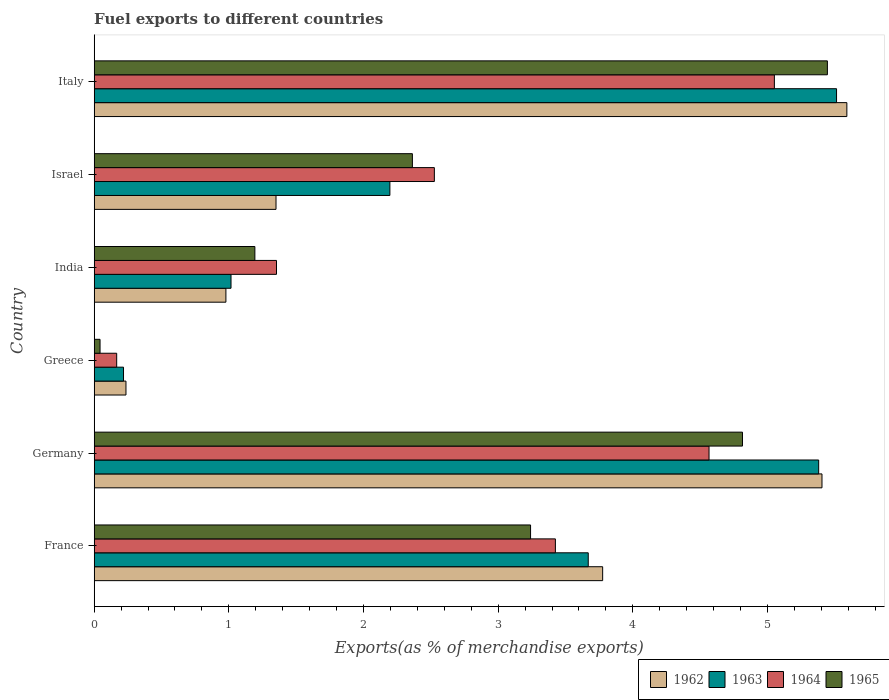How many different coloured bars are there?
Provide a succinct answer. 4. What is the label of the 5th group of bars from the top?
Ensure brevity in your answer.  Germany. In how many cases, is the number of bars for a given country not equal to the number of legend labels?
Give a very brief answer. 0. What is the percentage of exports to different countries in 1965 in Greece?
Your response must be concise. 0.04. Across all countries, what is the maximum percentage of exports to different countries in 1965?
Provide a succinct answer. 5.45. Across all countries, what is the minimum percentage of exports to different countries in 1962?
Your answer should be very brief. 0.24. In which country was the percentage of exports to different countries in 1963 maximum?
Give a very brief answer. Italy. In which country was the percentage of exports to different countries in 1963 minimum?
Give a very brief answer. Greece. What is the total percentage of exports to different countries in 1965 in the graph?
Ensure brevity in your answer.  17.1. What is the difference between the percentage of exports to different countries in 1963 in Greece and that in India?
Keep it short and to the point. -0.8. What is the difference between the percentage of exports to different countries in 1962 in Greece and the percentage of exports to different countries in 1965 in Italy?
Your answer should be compact. -5.21. What is the average percentage of exports to different countries in 1965 per country?
Provide a succinct answer. 2.85. What is the difference between the percentage of exports to different countries in 1962 and percentage of exports to different countries in 1965 in Israel?
Keep it short and to the point. -1.01. What is the ratio of the percentage of exports to different countries in 1962 in France to that in India?
Your response must be concise. 3.86. Is the percentage of exports to different countries in 1963 in India less than that in Israel?
Keep it short and to the point. Yes. Is the difference between the percentage of exports to different countries in 1962 in Germany and Italy greater than the difference between the percentage of exports to different countries in 1965 in Germany and Italy?
Your response must be concise. Yes. What is the difference between the highest and the second highest percentage of exports to different countries in 1963?
Offer a terse response. 0.13. What is the difference between the highest and the lowest percentage of exports to different countries in 1964?
Provide a short and direct response. 4.88. In how many countries, is the percentage of exports to different countries in 1962 greater than the average percentage of exports to different countries in 1962 taken over all countries?
Provide a short and direct response. 3. Is the sum of the percentage of exports to different countries in 1964 in Israel and Italy greater than the maximum percentage of exports to different countries in 1963 across all countries?
Your response must be concise. Yes. What does the 3rd bar from the bottom in France represents?
Make the answer very short. 1964. Is it the case that in every country, the sum of the percentage of exports to different countries in 1965 and percentage of exports to different countries in 1964 is greater than the percentage of exports to different countries in 1963?
Provide a short and direct response. No. What is the difference between two consecutive major ticks on the X-axis?
Make the answer very short. 1. Are the values on the major ticks of X-axis written in scientific E-notation?
Offer a very short reply. No. Does the graph contain any zero values?
Give a very brief answer. No. How are the legend labels stacked?
Ensure brevity in your answer.  Horizontal. What is the title of the graph?
Make the answer very short. Fuel exports to different countries. Does "1971" appear as one of the legend labels in the graph?
Make the answer very short. No. What is the label or title of the X-axis?
Ensure brevity in your answer.  Exports(as % of merchandise exports). What is the Exports(as % of merchandise exports) of 1962 in France?
Your answer should be compact. 3.78. What is the Exports(as % of merchandise exports) in 1963 in France?
Provide a short and direct response. 3.67. What is the Exports(as % of merchandise exports) of 1964 in France?
Keep it short and to the point. 3.43. What is the Exports(as % of merchandise exports) of 1965 in France?
Keep it short and to the point. 3.24. What is the Exports(as % of merchandise exports) of 1962 in Germany?
Offer a terse response. 5.4. What is the Exports(as % of merchandise exports) in 1963 in Germany?
Offer a terse response. 5.38. What is the Exports(as % of merchandise exports) in 1964 in Germany?
Your answer should be very brief. 4.57. What is the Exports(as % of merchandise exports) of 1965 in Germany?
Your response must be concise. 4.81. What is the Exports(as % of merchandise exports) of 1962 in Greece?
Offer a very short reply. 0.24. What is the Exports(as % of merchandise exports) in 1963 in Greece?
Provide a succinct answer. 0.22. What is the Exports(as % of merchandise exports) in 1964 in Greece?
Provide a succinct answer. 0.17. What is the Exports(as % of merchandise exports) in 1965 in Greece?
Your response must be concise. 0.04. What is the Exports(as % of merchandise exports) in 1962 in India?
Make the answer very short. 0.98. What is the Exports(as % of merchandise exports) in 1963 in India?
Keep it short and to the point. 1.02. What is the Exports(as % of merchandise exports) of 1964 in India?
Your answer should be very brief. 1.35. What is the Exports(as % of merchandise exports) in 1965 in India?
Keep it short and to the point. 1.19. What is the Exports(as % of merchandise exports) in 1962 in Israel?
Offer a very short reply. 1.35. What is the Exports(as % of merchandise exports) of 1963 in Israel?
Your answer should be compact. 2.2. What is the Exports(as % of merchandise exports) of 1964 in Israel?
Keep it short and to the point. 2.53. What is the Exports(as % of merchandise exports) in 1965 in Israel?
Provide a short and direct response. 2.36. What is the Exports(as % of merchandise exports) in 1962 in Italy?
Provide a succinct answer. 5.59. What is the Exports(as % of merchandise exports) in 1963 in Italy?
Ensure brevity in your answer.  5.51. What is the Exports(as % of merchandise exports) of 1964 in Italy?
Your answer should be compact. 5.05. What is the Exports(as % of merchandise exports) in 1965 in Italy?
Ensure brevity in your answer.  5.45. Across all countries, what is the maximum Exports(as % of merchandise exports) in 1962?
Provide a short and direct response. 5.59. Across all countries, what is the maximum Exports(as % of merchandise exports) of 1963?
Your response must be concise. 5.51. Across all countries, what is the maximum Exports(as % of merchandise exports) of 1964?
Provide a short and direct response. 5.05. Across all countries, what is the maximum Exports(as % of merchandise exports) in 1965?
Provide a succinct answer. 5.45. Across all countries, what is the minimum Exports(as % of merchandise exports) of 1962?
Provide a succinct answer. 0.24. Across all countries, what is the minimum Exports(as % of merchandise exports) of 1963?
Your answer should be compact. 0.22. Across all countries, what is the minimum Exports(as % of merchandise exports) in 1964?
Your answer should be compact. 0.17. Across all countries, what is the minimum Exports(as % of merchandise exports) of 1965?
Your answer should be compact. 0.04. What is the total Exports(as % of merchandise exports) of 1962 in the graph?
Offer a terse response. 17.34. What is the total Exports(as % of merchandise exports) of 1963 in the graph?
Provide a short and direct response. 17.99. What is the total Exports(as % of merchandise exports) in 1964 in the graph?
Offer a very short reply. 17.09. What is the total Exports(as % of merchandise exports) in 1965 in the graph?
Ensure brevity in your answer.  17.1. What is the difference between the Exports(as % of merchandise exports) in 1962 in France and that in Germany?
Provide a succinct answer. -1.63. What is the difference between the Exports(as % of merchandise exports) of 1963 in France and that in Germany?
Your answer should be compact. -1.71. What is the difference between the Exports(as % of merchandise exports) in 1964 in France and that in Germany?
Offer a very short reply. -1.14. What is the difference between the Exports(as % of merchandise exports) of 1965 in France and that in Germany?
Offer a very short reply. -1.57. What is the difference between the Exports(as % of merchandise exports) of 1962 in France and that in Greece?
Give a very brief answer. 3.54. What is the difference between the Exports(as % of merchandise exports) in 1963 in France and that in Greece?
Ensure brevity in your answer.  3.45. What is the difference between the Exports(as % of merchandise exports) in 1964 in France and that in Greece?
Give a very brief answer. 3.26. What is the difference between the Exports(as % of merchandise exports) in 1965 in France and that in Greece?
Offer a terse response. 3.2. What is the difference between the Exports(as % of merchandise exports) of 1962 in France and that in India?
Keep it short and to the point. 2.8. What is the difference between the Exports(as % of merchandise exports) in 1963 in France and that in India?
Your answer should be very brief. 2.65. What is the difference between the Exports(as % of merchandise exports) of 1964 in France and that in India?
Give a very brief answer. 2.07. What is the difference between the Exports(as % of merchandise exports) in 1965 in France and that in India?
Your response must be concise. 2.05. What is the difference between the Exports(as % of merchandise exports) in 1962 in France and that in Israel?
Your response must be concise. 2.43. What is the difference between the Exports(as % of merchandise exports) in 1963 in France and that in Israel?
Keep it short and to the point. 1.47. What is the difference between the Exports(as % of merchandise exports) of 1964 in France and that in Israel?
Offer a very short reply. 0.9. What is the difference between the Exports(as % of merchandise exports) of 1965 in France and that in Israel?
Your response must be concise. 0.88. What is the difference between the Exports(as % of merchandise exports) in 1962 in France and that in Italy?
Your answer should be compact. -1.81. What is the difference between the Exports(as % of merchandise exports) in 1963 in France and that in Italy?
Give a very brief answer. -1.84. What is the difference between the Exports(as % of merchandise exports) in 1964 in France and that in Italy?
Your response must be concise. -1.63. What is the difference between the Exports(as % of merchandise exports) in 1965 in France and that in Italy?
Offer a very short reply. -2.2. What is the difference between the Exports(as % of merchandise exports) of 1962 in Germany and that in Greece?
Provide a succinct answer. 5.17. What is the difference between the Exports(as % of merchandise exports) in 1963 in Germany and that in Greece?
Provide a succinct answer. 5.16. What is the difference between the Exports(as % of merchandise exports) of 1964 in Germany and that in Greece?
Provide a succinct answer. 4.4. What is the difference between the Exports(as % of merchandise exports) of 1965 in Germany and that in Greece?
Your answer should be compact. 4.77. What is the difference between the Exports(as % of merchandise exports) of 1962 in Germany and that in India?
Make the answer very short. 4.43. What is the difference between the Exports(as % of merchandise exports) of 1963 in Germany and that in India?
Provide a succinct answer. 4.36. What is the difference between the Exports(as % of merchandise exports) in 1964 in Germany and that in India?
Your answer should be very brief. 3.21. What is the difference between the Exports(as % of merchandise exports) in 1965 in Germany and that in India?
Offer a terse response. 3.62. What is the difference between the Exports(as % of merchandise exports) of 1962 in Germany and that in Israel?
Your answer should be very brief. 4.05. What is the difference between the Exports(as % of merchandise exports) in 1963 in Germany and that in Israel?
Ensure brevity in your answer.  3.18. What is the difference between the Exports(as % of merchandise exports) in 1964 in Germany and that in Israel?
Your response must be concise. 2.04. What is the difference between the Exports(as % of merchandise exports) in 1965 in Germany and that in Israel?
Give a very brief answer. 2.45. What is the difference between the Exports(as % of merchandise exports) of 1962 in Germany and that in Italy?
Your response must be concise. -0.18. What is the difference between the Exports(as % of merchandise exports) of 1963 in Germany and that in Italy?
Make the answer very short. -0.13. What is the difference between the Exports(as % of merchandise exports) in 1964 in Germany and that in Italy?
Ensure brevity in your answer.  -0.49. What is the difference between the Exports(as % of merchandise exports) of 1965 in Germany and that in Italy?
Keep it short and to the point. -0.63. What is the difference between the Exports(as % of merchandise exports) of 1962 in Greece and that in India?
Ensure brevity in your answer.  -0.74. What is the difference between the Exports(as % of merchandise exports) of 1963 in Greece and that in India?
Keep it short and to the point. -0.8. What is the difference between the Exports(as % of merchandise exports) of 1964 in Greece and that in India?
Ensure brevity in your answer.  -1.19. What is the difference between the Exports(as % of merchandise exports) of 1965 in Greece and that in India?
Provide a short and direct response. -1.15. What is the difference between the Exports(as % of merchandise exports) in 1962 in Greece and that in Israel?
Your answer should be very brief. -1.11. What is the difference between the Exports(as % of merchandise exports) of 1963 in Greece and that in Israel?
Ensure brevity in your answer.  -1.98. What is the difference between the Exports(as % of merchandise exports) in 1964 in Greece and that in Israel?
Give a very brief answer. -2.36. What is the difference between the Exports(as % of merchandise exports) in 1965 in Greece and that in Israel?
Offer a very short reply. -2.32. What is the difference between the Exports(as % of merchandise exports) of 1962 in Greece and that in Italy?
Make the answer very short. -5.35. What is the difference between the Exports(as % of merchandise exports) in 1963 in Greece and that in Italy?
Provide a short and direct response. -5.3. What is the difference between the Exports(as % of merchandise exports) in 1964 in Greece and that in Italy?
Offer a terse response. -4.88. What is the difference between the Exports(as % of merchandise exports) of 1965 in Greece and that in Italy?
Your answer should be compact. -5.4. What is the difference between the Exports(as % of merchandise exports) of 1962 in India and that in Israel?
Your answer should be compact. -0.37. What is the difference between the Exports(as % of merchandise exports) in 1963 in India and that in Israel?
Provide a short and direct response. -1.18. What is the difference between the Exports(as % of merchandise exports) in 1964 in India and that in Israel?
Provide a short and direct response. -1.17. What is the difference between the Exports(as % of merchandise exports) of 1965 in India and that in Israel?
Give a very brief answer. -1.17. What is the difference between the Exports(as % of merchandise exports) in 1962 in India and that in Italy?
Your answer should be very brief. -4.61. What is the difference between the Exports(as % of merchandise exports) of 1963 in India and that in Italy?
Your response must be concise. -4.5. What is the difference between the Exports(as % of merchandise exports) in 1964 in India and that in Italy?
Your response must be concise. -3.7. What is the difference between the Exports(as % of merchandise exports) of 1965 in India and that in Italy?
Offer a terse response. -4.25. What is the difference between the Exports(as % of merchandise exports) of 1962 in Israel and that in Italy?
Ensure brevity in your answer.  -4.24. What is the difference between the Exports(as % of merchandise exports) of 1963 in Israel and that in Italy?
Keep it short and to the point. -3.32. What is the difference between the Exports(as % of merchandise exports) of 1964 in Israel and that in Italy?
Provide a short and direct response. -2.53. What is the difference between the Exports(as % of merchandise exports) of 1965 in Israel and that in Italy?
Offer a terse response. -3.08. What is the difference between the Exports(as % of merchandise exports) of 1962 in France and the Exports(as % of merchandise exports) of 1963 in Germany?
Your answer should be very brief. -1.6. What is the difference between the Exports(as % of merchandise exports) of 1962 in France and the Exports(as % of merchandise exports) of 1964 in Germany?
Ensure brevity in your answer.  -0.79. What is the difference between the Exports(as % of merchandise exports) of 1962 in France and the Exports(as % of merchandise exports) of 1965 in Germany?
Make the answer very short. -1.04. What is the difference between the Exports(as % of merchandise exports) in 1963 in France and the Exports(as % of merchandise exports) in 1964 in Germany?
Keep it short and to the point. -0.9. What is the difference between the Exports(as % of merchandise exports) of 1963 in France and the Exports(as % of merchandise exports) of 1965 in Germany?
Offer a terse response. -1.15. What is the difference between the Exports(as % of merchandise exports) in 1964 in France and the Exports(as % of merchandise exports) in 1965 in Germany?
Keep it short and to the point. -1.39. What is the difference between the Exports(as % of merchandise exports) of 1962 in France and the Exports(as % of merchandise exports) of 1963 in Greece?
Make the answer very short. 3.56. What is the difference between the Exports(as % of merchandise exports) of 1962 in France and the Exports(as % of merchandise exports) of 1964 in Greece?
Ensure brevity in your answer.  3.61. What is the difference between the Exports(as % of merchandise exports) in 1962 in France and the Exports(as % of merchandise exports) in 1965 in Greece?
Your response must be concise. 3.73. What is the difference between the Exports(as % of merchandise exports) in 1963 in France and the Exports(as % of merchandise exports) in 1964 in Greece?
Your response must be concise. 3.5. What is the difference between the Exports(as % of merchandise exports) of 1963 in France and the Exports(as % of merchandise exports) of 1965 in Greece?
Offer a very short reply. 3.63. What is the difference between the Exports(as % of merchandise exports) of 1964 in France and the Exports(as % of merchandise exports) of 1965 in Greece?
Provide a succinct answer. 3.38. What is the difference between the Exports(as % of merchandise exports) in 1962 in France and the Exports(as % of merchandise exports) in 1963 in India?
Your answer should be very brief. 2.76. What is the difference between the Exports(as % of merchandise exports) in 1962 in France and the Exports(as % of merchandise exports) in 1964 in India?
Your answer should be very brief. 2.42. What is the difference between the Exports(as % of merchandise exports) in 1962 in France and the Exports(as % of merchandise exports) in 1965 in India?
Your response must be concise. 2.58. What is the difference between the Exports(as % of merchandise exports) of 1963 in France and the Exports(as % of merchandise exports) of 1964 in India?
Give a very brief answer. 2.32. What is the difference between the Exports(as % of merchandise exports) in 1963 in France and the Exports(as % of merchandise exports) in 1965 in India?
Provide a short and direct response. 2.48. What is the difference between the Exports(as % of merchandise exports) of 1964 in France and the Exports(as % of merchandise exports) of 1965 in India?
Give a very brief answer. 2.23. What is the difference between the Exports(as % of merchandise exports) of 1962 in France and the Exports(as % of merchandise exports) of 1963 in Israel?
Make the answer very short. 1.58. What is the difference between the Exports(as % of merchandise exports) of 1962 in France and the Exports(as % of merchandise exports) of 1964 in Israel?
Your answer should be compact. 1.25. What is the difference between the Exports(as % of merchandise exports) of 1962 in France and the Exports(as % of merchandise exports) of 1965 in Israel?
Provide a short and direct response. 1.41. What is the difference between the Exports(as % of merchandise exports) in 1963 in France and the Exports(as % of merchandise exports) in 1964 in Israel?
Give a very brief answer. 1.14. What is the difference between the Exports(as % of merchandise exports) in 1963 in France and the Exports(as % of merchandise exports) in 1965 in Israel?
Keep it short and to the point. 1.31. What is the difference between the Exports(as % of merchandise exports) of 1964 in France and the Exports(as % of merchandise exports) of 1965 in Israel?
Provide a short and direct response. 1.06. What is the difference between the Exports(as % of merchandise exports) in 1962 in France and the Exports(as % of merchandise exports) in 1963 in Italy?
Your answer should be very brief. -1.74. What is the difference between the Exports(as % of merchandise exports) in 1962 in France and the Exports(as % of merchandise exports) in 1964 in Italy?
Your answer should be compact. -1.28. What is the difference between the Exports(as % of merchandise exports) in 1962 in France and the Exports(as % of merchandise exports) in 1965 in Italy?
Ensure brevity in your answer.  -1.67. What is the difference between the Exports(as % of merchandise exports) of 1963 in France and the Exports(as % of merchandise exports) of 1964 in Italy?
Give a very brief answer. -1.38. What is the difference between the Exports(as % of merchandise exports) of 1963 in France and the Exports(as % of merchandise exports) of 1965 in Italy?
Provide a succinct answer. -1.78. What is the difference between the Exports(as % of merchandise exports) in 1964 in France and the Exports(as % of merchandise exports) in 1965 in Italy?
Ensure brevity in your answer.  -2.02. What is the difference between the Exports(as % of merchandise exports) in 1962 in Germany and the Exports(as % of merchandise exports) in 1963 in Greece?
Your answer should be compact. 5.19. What is the difference between the Exports(as % of merchandise exports) in 1962 in Germany and the Exports(as % of merchandise exports) in 1964 in Greece?
Provide a succinct answer. 5.24. What is the difference between the Exports(as % of merchandise exports) of 1962 in Germany and the Exports(as % of merchandise exports) of 1965 in Greece?
Your answer should be compact. 5.36. What is the difference between the Exports(as % of merchandise exports) in 1963 in Germany and the Exports(as % of merchandise exports) in 1964 in Greece?
Your answer should be compact. 5.21. What is the difference between the Exports(as % of merchandise exports) in 1963 in Germany and the Exports(as % of merchandise exports) in 1965 in Greece?
Make the answer very short. 5.34. What is the difference between the Exports(as % of merchandise exports) in 1964 in Germany and the Exports(as % of merchandise exports) in 1965 in Greece?
Give a very brief answer. 4.52. What is the difference between the Exports(as % of merchandise exports) of 1962 in Germany and the Exports(as % of merchandise exports) of 1963 in India?
Offer a terse response. 4.39. What is the difference between the Exports(as % of merchandise exports) in 1962 in Germany and the Exports(as % of merchandise exports) in 1964 in India?
Give a very brief answer. 4.05. What is the difference between the Exports(as % of merchandise exports) in 1962 in Germany and the Exports(as % of merchandise exports) in 1965 in India?
Offer a terse response. 4.21. What is the difference between the Exports(as % of merchandise exports) of 1963 in Germany and the Exports(as % of merchandise exports) of 1964 in India?
Ensure brevity in your answer.  4.03. What is the difference between the Exports(as % of merchandise exports) of 1963 in Germany and the Exports(as % of merchandise exports) of 1965 in India?
Provide a succinct answer. 4.19. What is the difference between the Exports(as % of merchandise exports) of 1964 in Germany and the Exports(as % of merchandise exports) of 1965 in India?
Provide a short and direct response. 3.37. What is the difference between the Exports(as % of merchandise exports) of 1962 in Germany and the Exports(as % of merchandise exports) of 1963 in Israel?
Provide a short and direct response. 3.21. What is the difference between the Exports(as % of merchandise exports) of 1962 in Germany and the Exports(as % of merchandise exports) of 1964 in Israel?
Give a very brief answer. 2.88. What is the difference between the Exports(as % of merchandise exports) in 1962 in Germany and the Exports(as % of merchandise exports) in 1965 in Israel?
Keep it short and to the point. 3.04. What is the difference between the Exports(as % of merchandise exports) in 1963 in Germany and the Exports(as % of merchandise exports) in 1964 in Israel?
Offer a very short reply. 2.85. What is the difference between the Exports(as % of merchandise exports) in 1963 in Germany and the Exports(as % of merchandise exports) in 1965 in Israel?
Offer a terse response. 3.02. What is the difference between the Exports(as % of merchandise exports) of 1964 in Germany and the Exports(as % of merchandise exports) of 1965 in Israel?
Provide a short and direct response. 2.2. What is the difference between the Exports(as % of merchandise exports) of 1962 in Germany and the Exports(as % of merchandise exports) of 1963 in Italy?
Offer a terse response. -0.11. What is the difference between the Exports(as % of merchandise exports) in 1962 in Germany and the Exports(as % of merchandise exports) in 1964 in Italy?
Offer a very short reply. 0.35. What is the difference between the Exports(as % of merchandise exports) of 1962 in Germany and the Exports(as % of merchandise exports) of 1965 in Italy?
Your answer should be compact. -0.04. What is the difference between the Exports(as % of merchandise exports) of 1963 in Germany and the Exports(as % of merchandise exports) of 1964 in Italy?
Make the answer very short. 0.33. What is the difference between the Exports(as % of merchandise exports) of 1963 in Germany and the Exports(as % of merchandise exports) of 1965 in Italy?
Keep it short and to the point. -0.06. What is the difference between the Exports(as % of merchandise exports) of 1964 in Germany and the Exports(as % of merchandise exports) of 1965 in Italy?
Your response must be concise. -0.88. What is the difference between the Exports(as % of merchandise exports) of 1962 in Greece and the Exports(as % of merchandise exports) of 1963 in India?
Your response must be concise. -0.78. What is the difference between the Exports(as % of merchandise exports) in 1962 in Greece and the Exports(as % of merchandise exports) in 1964 in India?
Your response must be concise. -1.12. What is the difference between the Exports(as % of merchandise exports) in 1962 in Greece and the Exports(as % of merchandise exports) in 1965 in India?
Give a very brief answer. -0.96. What is the difference between the Exports(as % of merchandise exports) of 1963 in Greece and the Exports(as % of merchandise exports) of 1964 in India?
Your response must be concise. -1.14. What is the difference between the Exports(as % of merchandise exports) in 1963 in Greece and the Exports(as % of merchandise exports) in 1965 in India?
Provide a short and direct response. -0.98. What is the difference between the Exports(as % of merchandise exports) in 1964 in Greece and the Exports(as % of merchandise exports) in 1965 in India?
Your answer should be compact. -1.03. What is the difference between the Exports(as % of merchandise exports) of 1962 in Greece and the Exports(as % of merchandise exports) of 1963 in Israel?
Give a very brief answer. -1.96. What is the difference between the Exports(as % of merchandise exports) of 1962 in Greece and the Exports(as % of merchandise exports) of 1964 in Israel?
Your answer should be compact. -2.29. What is the difference between the Exports(as % of merchandise exports) of 1962 in Greece and the Exports(as % of merchandise exports) of 1965 in Israel?
Your response must be concise. -2.13. What is the difference between the Exports(as % of merchandise exports) in 1963 in Greece and the Exports(as % of merchandise exports) in 1964 in Israel?
Offer a terse response. -2.31. What is the difference between the Exports(as % of merchandise exports) of 1963 in Greece and the Exports(as % of merchandise exports) of 1965 in Israel?
Offer a terse response. -2.15. What is the difference between the Exports(as % of merchandise exports) of 1964 in Greece and the Exports(as % of merchandise exports) of 1965 in Israel?
Keep it short and to the point. -2.2. What is the difference between the Exports(as % of merchandise exports) of 1962 in Greece and the Exports(as % of merchandise exports) of 1963 in Italy?
Offer a very short reply. -5.28. What is the difference between the Exports(as % of merchandise exports) in 1962 in Greece and the Exports(as % of merchandise exports) in 1964 in Italy?
Make the answer very short. -4.82. What is the difference between the Exports(as % of merchandise exports) in 1962 in Greece and the Exports(as % of merchandise exports) in 1965 in Italy?
Provide a short and direct response. -5.21. What is the difference between the Exports(as % of merchandise exports) of 1963 in Greece and the Exports(as % of merchandise exports) of 1964 in Italy?
Your answer should be very brief. -4.83. What is the difference between the Exports(as % of merchandise exports) in 1963 in Greece and the Exports(as % of merchandise exports) in 1965 in Italy?
Offer a terse response. -5.23. What is the difference between the Exports(as % of merchandise exports) of 1964 in Greece and the Exports(as % of merchandise exports) of 1965 in Italy?
Provide a short and direct response. -5.28. What is the difference between the Exports(as % of merchandise exports) in 1962 in India and the Exports(as % of merchandise exports) in 1963 in Israel?
Give a very brief answer. -1.22. What is the difference between the Exports(as % of merchandise exports) of 1962 in India and the Exports(as % of merchandise exports) of 1964 in Israel?
Provide a short and direct response. -1.55. What is the difference between the Exports(as % of merchandise exports) in 1962 in India and the Exports(as % of merchandise exports) in 1965 in Israel?
Offer a terse response. -1.38. What is the difference between the Exports(as % of merchandise exports) in 1963 in India and the Exports(as % of merchandise exports) in 1964 in Israel?
Your answer should be very brief. -1.51. What is the difference between the Exports(as % of merchandise exports) of 1963 in India and the Exports(as % of merchandise exports) of 1965 in Israel?
Keep it short and to the point. -1.35. What is the difference between the Exports(as % of merchandise exports) of 1964 in India and the Exports(as % of merchandise exports) of 1965 in Israel?
Your answer should be very brief. -1.01. What is the difference between the Exports(as % of merchandise exports) in 1962 in India and the Exports(as % of merchandise exports) in 1963 in Italy?
Your answer should be compact. -4.54. What is the difference between the Exports(as % of merchandise exports) in 1962 in India and the Exports(as % of merchandise exports) in 1964 in Italy?
Your answer should be compact. -4.07. What is the difference between the Exports(as % of merchandise exports) in 1962 in India and the Exports(as % of merchandise exports) in 1965 in Italy?
Ensure brevity in your answer.  -4.47. What is the difference between the Exports(as % of merchandise exports) of 1963 in India and the Exports(as % of merchandise exports) of 1964 in Italy?
Make the answer very short. -4.04. What is the difference between the Exports(as % of merchandise exports) in 1963 in India and the Exports(as % of merchandise exports) in 1965 in Italy?
Make the answer very short. -4.43. What is the difference between the Exports(as % of merchandise exports) in 1964 in India and the Exports(as % of merchandise exports) in 1965 in Italy?
Make the answer very short. -4.09. What is the difference between the Exports(as % of merchandise exports) of 1962 in Israel and the Exports(as % of merchandise exports) of 1963 in Italy?
Offer a terse response. -4.16. What is the difference between the Exports(as % of merchandise exports) of 1962 in Israel and the Exports(as % of merchandise exports) of 1964 in Italy?
Your response must be concise. -3.7. What is the difference between the Exports(as % of merchandise exports) in 1962 in Israel and the Exports(as % of merchandise exports) in 1965 in Italy?
Your answer should be compact. -4.09. What is the difference between the Exports(as % of merchandise exports) in 1963 in Israel and the Exports(as % of merchandise exports) in 1964 in Italy?
Make the answer very short. -2.86. What is the difference between the Exports(as % of merchandise exports) of 1963 in Israel and the Exports(as % of merchandise exports) of 1965 in Italy?
Provide a succinct answer. -3.25. What is the difference between the Exports(as % of merchandise exports) in 1964 in Israel and the Exports(as % of merchandise exports) in 1965 in Italy?
Offer a terse response. -2.92. What is the average Exports(as % of merchandise exports) of 1962 per country?
Keep it short and to the point. 2.89. What is the average Exports(as % of merchandise exports) of 1963 per country?
Provide a succinct answer. 3. What is the average Exports(as % of merchandise exports) in 1964 per country?
Your response must be concise. 2.85. What is the average Exports(as % of merchandise exports) of 1965 per country?
Your answer should be very brief. 2.85. What is the difference between the Exports(as % of merchandise exports) of 1962 and Exports(as % of merchandise exports) of 1963 in France?
Make the answer very short. 0.11. What is the difference between the Exports(as % of merchandise exports) in 1962 and Exports(as % of merchandise exports) in 1964 in France?
Your answer should be very brief. 0.35. What is the difference between the Exports(as % of merchandise exports) of 1962 and Exports(as % of merchandise exports) of 1965 in France?
Ensure brevity in your answer.  0.54. What is the difference between the Exports(as % of merchandise exports) of 1963 and Exports(as % of merchandise exports) of 1964 in France?
Your response must be concise. 0.24. What is the difference between the Exports(as % of merchandise exports) of 1963 and Exports(as % of merchandise exports) of 1965 in France?
Offer a terse response. 0.43. What is the difference between the Exports(as % of merchandise exports) in 1964 and Exports(as % of merchandise exports) in 1965 in France?
Give a very brief answer. 0.18. What is the difference between the Exports(as % of merchandise exports) of 1962 and Exports(as % of merchandise exports) of 1963 in Germany?
Keep it short and to the point. 0.02. What is the difference between the Exports(as % of merchandise exports) in 1962 and Exports(as % of merchandise exports) in 1964 in Germany?
Your answer should be compact. 0.84. What is the difference between the Exports(as % of merchandise exports) in 1962 and Exports(as % of merchandise exports) in 1965 in Germany?
Provide a short and direct response. 0.59. What is the difference between the Exports(as % of merchandise exports) in 1963 and Exports(as % of merchandise exports) in 1964 in Germany?
Make the answer very short. 0.81. What is the difference between the Exports(as % of merchandise exports) in 1963 and Exports(as % of merchandise exports) in 1965 in Germany?
Ensure brevity in your answer.  0.57. What is the difference between the Exports(as % of merchandise exports) of 1964 and Exports(as % of merchandise exports) of 1965 in Germany?
Your answer should be compact. -0.25. What is the difference between the Exports(as % of merchandise exports) in 1962 and Exports(as % of merchandise exports) in 1963 in Greece?
Keep it short and to the point. 0.02. What is the difference between the Exports(as % of merchandise exports) in 1962 and Exports(as % of merchandise exports) in 1964 in Greece?
Give a very brief answer. 0.07. What is the difference between the Exports(as % of merchandise exports) in 1962 and Exports(as % of merchandise exports) in 1965 in Greece?
Provide a succinct answer. 0.19. What is the difference between the Exports(as % of merchandise exports) in 1963 and Exports(as % of merchandise exports) in 1964 in Greece?
Provide a succinct answer. 0.05. What is the difference between the Exports(as % of merchandise exports) of 1963 and Exports(as % of merchandise exports) of 1965 in Greece?
Offer a terse response. 0.17. What is the difference between the Exports(as % of merchandise exports) of 1964 and Exports(as % of merchandise exports) of 1965 in Greece?
Make the answer very short. 0.12. What is the difference between the Exports(as % of merchandise exports) of 1962 and Exports(as % of merchandise exports) of 1963 in India?
Offer a terse response. -0.04. What is the difference between the Exports(as % of merchandise exports) in 1962 and Exports(as % of merchandise exports) in 1964 in India?
Offer a terse response. -0.38. What is the difference between the Exports(as % of merchandise exports) of 1962 and Exports(as % of merchandise exports) of 1965 in India?
Offer a very short reply. -0.22. What is the difference between the Exports(as % of merchandise exports) in 1963 and Exports(as % of merchandise exports) in 1964 in India?
Offer a very short reply. -0.34. What is the difference between the Exports(as % of merchandise exports) in 1963 and Exports(as % of merchandise exports) in 1965 in India?
Your answer should be compact. -0.18. What is the difference between the Exports(as % of merchandise exports) in 1964 and Exports(as % of merchandise exports) in 1965 in India?
Give a very brief answer. 0.16. What is the difference between the Exports(as % of merchandise exports) of 1962 and Exports(as % of merchandise exports) of 1963 in Israel?
Offer a very short reply. -0.85. What is the difference between the Exports(as % of merchandise exports) of 1962 and Exports(as % of merchandise exports) of 1964 in Israel?
Offer a terse response. -1.18. What is the difference between the Exports(as % of merchandise exports) of 1962 and Exports(as % of merchandise exports) of 1965 in Israel?
Provide a short and direct response. -1.01. What is the difference between the Exports(as % of merchandise exports) in 1963 and Exports(as % of merchandise exports) in 1964 in Israel?
Ensure brevity in your answer.  -0.33. What is the difference between the Exports(as % of merchandise exports) in 1963 and Exports(as % of merchandise exports) in 1965 in Israel?
Provide a short and direct response. -0.17. What is the difference between the Exports(as % of merchandise exports) of 1964 and Exports(as % of merchandise exports) of 1965 in Israel?
Offer a very short reply. 0.16. What is the difference between the Exports(as % of merchandise exports) in 1962 and Exports(as % of merchandise exports) in 1963 in Italy?
Offer a very short reply. 0.08. What is the difference between the Exports(as % of merchandise exports) in 1962 and Exports(as % of merchandise exports) in 1964 in Italy?
Give a very brief answer. 0.54. What is the difference between the Exports(as % of merchandise exports) of 1962 and Exports(as % of merchandise exports) of 1965 in Italy?
Keep it short and to the point. 0.14. What is the difference between the Exports(as % of merchandise exports) of 1963 and Exports(as % of merchandise exports) of 1964 in Italy?
Give a very brief answer. 0.46. What is the difference between the Exports(as % of merchandise exports) in 1963 and Exports(as % of merchandise exports) in 1965 in Italy?
Offer a very short reply. 0.07. What is the difference between the Exports(as % of merchandise exports) in 1964 and Exports(as % of merchandise exports) in 1965 in Italy?
Ensure brevity in your answer.  -0.39. What is the ratio of the Exports(as % of merchandise exports) of 1962 in France to that in Germany?
Keep it short and to the point. 0.7. What is the ratio of the Exports(as % of merchandise exports) of 1963 in France to that in Germany?
Ensure brevity in your answer.  0.68. What is the ratio of the Exports(as % of merchandise exports) of 1964 in France to that in Germany?
Offer a very short reply. 0.75. What is the ratio of the Exports(as % of merchandise exports) in 1965 in France to that in Germany?
Make the answer very short. 0.67. What is the ratio of the Exports(as % of merchandise exports) of 1962 in France to that in Greece?
Your answer should be very brief. 16.01. What is the ratio of the Exports(as % of merchandise exports) of 1963 in France to that in Greece?
Provide a short and direct response. 16.85. What is the ratio of the Exports(as % of merchandise exports) in 1964 in France to that in Greece?
Keep it short and to the point. 20.5. What is the ratio of the Exports(as % of merchandise exports) of 1965 in France to that in Greece?
Provide a succinct answer. 74.69. What is the ratio of the Exports(as % of merchandise exports) of 1962 in France to that in India?
Your answer should be compact. 3.86. What is the ratio of the Exports(as % of merchandise exports) in 1963 in France to that in India?
Provide a succinct answer. 3.61. What is the ratio of the Exports(as % of merchandise exports) in 1964 in France to that in India?
Your answer should be compact. 2.53. What is the ratio of the Exports(as % of merchandise exports) of 1965 in France to that in India?
Offer a terse response. 2.72. What is the ratio of the Exports(as % of merchandise exports) of 1962 in France to that in Israel?
Give a very brief answer. 2.8. What is the ratio of the Exports(as % of merchandise exports) of 1963 in France to that in Israel?
Your answer should be compact. 1.67. What is the ratio of the Exports(as % of merchandise exports) in 1964 in France to that in Israel?
Your answer should be compact. 1.36. What is the ratio of the Exports(as % of merchandise exports) of 1965 in France to that in Israel?
Keep it short and to the point. 1.37. What is the ratio of the Exports(as % of merchandise exports) in 1962 in France to that in Italy?
Give a very brief answer. 0.68. What is the ratio of the Exports(as % of merchandise exports) of 1963 in France to that in Italy?
Make the answer very short. 0.67. What is the ratio of the Exports(as % of merchandise exports) of 1964 in France to that in Italy?
Ensure brevity in your answer.  0.68. What is the ratio of the Exports(as % of merchandise exports) in 1965 in France to that in Italy?
Your answer should be very brief. 0.6. What is the ratio of the Exports(as % of merchandise exports) in 1962 in Germany to that in Greece?
Make the answer very short. 22.91. What is the ratio of the Exports(as % of merchandise exports) of 1963 in Germany to that in Greece?
Your answer should be compact. 24.71. What is the ratio of the Exports(as % of merchandise exports) of 1964 in Germany to that in Greece?
Offer a terse response. 27.34. What is the ratio of the Exports(as % of merchandise exports) of 1965 in Germany to that in Greece?
Provide a succinct answer. 110.96. What is the ratio of the Exports(as % of merchandise exports) in 1962 in Germany to that in India?
Your response must be concise. 5.53. What is the ratio of the Exports(as % of merchandise exports) of 1963 in Germany to that in India?
Your answer should be compact. 5.3. What is the ratio of the Exports(as % of merchandise exports) in 1964 in Germany to that in India?
Make the answer very short. 3.37. What is the ratio of the Exports(as % of merchandise exports) in 1965 in Germany to that in India?
Offer a very short reply. 4.03. What is the ratio of the Exports(as % of merchandise exports) in 1962 in Germany to that in Israel?
Offer a very short reply. 4. What is the ratio of the Exports(as % of merchandise exports) of 1963 in Germany to that in Israel?
Your answer should be compact. 2.45. What is the ratio of the Exports(as % of merchandise exports) in 1964 in Germany to that in Israel?
Offer a terse response. 1.81. What is the ratio of the Exports(as % of merchandise exports) in 1965 in Germany to that in Israel?
Your answer should be compact. 2.04. What is the ratio of the Exports(as % of merchandise exports) of 1962 in Germany to that in Italy?
Provide a short and direct response. 0.97. What is the ratio of the Exports(as % of merchandise exports) of 1963 in Germany to that in Italy?
Provide a succinct answer. 0.98. What is the ratio of the Exports(as % of merchandise exports) in 1964 in Germany to that in Italy?
Your response must be concise. 0.9. What is the ratio of the Exports(as % of merchandise exports) of 1965 in Germany to that in Italy?
Make the answer very short. 0.88. What is the ratio of the Exports(as % of merchandise exports) in 1962 in Greece to that in India?
Offer a very short reply. 0.24. What is the ratio of the Exports(as % of merchandise exports) of 1963 in Greece to that in India?
Your response must be concise. 0.21. What is the ratio of the Exports(as % of merchandise exports) in 1964 in Greece to that in India?
Your answer should be compact. 0.12. What is the ratio of the Exports(as % of merchandise exports) of 1965 in Greece to that in India?
Give a very brief answer. 0.04. What is the ratio of the Exports(as % of merchandise exports) in 1962 in Greece to that in Israel?
Keep it short and to the point. 0.17. What is the ratio of the Exports(as % of merchandise exports) of 1963 in Greece to that in Israel?
Your answer should be compact. 0.1. What is the ratio of the Exports(as % of merchandise exports) of 1964 in Greece to that in Israel?
Ensure brevity in your answer.  0.07. What is the ratio of the Exports(as % of merchandise exports) of 1965 in Greece to that in Israel?
Offer a very short reply. 0.02. What is the ratio of the Exports(as % of merchandise exports) of 1962 in Greece to that in Italy?
Your response must be concise. 0.04. What is the ratio of the Exports(as % of merchandise exports) in 1963 in Greece to that in Italy?
Provide a succinct answer. 0.04. What is the ratio of the Exports(as % of merchandise exports) of 1964 in Greece to that in Italy?
Keep it short and to the point. 0.03. What is the ratio of the Exports(as % of merchandise exports) of 1965 in Greece to that in Italy?
Offer a terse response. 0.01. What is the ratio of the Exports(as % of merchandise exports) in 1962 in India to that in Israel?
Keep it short and to the point. 0.72. What is the ratio of the Exports(as % of merchandise exports) in 1963 in India to that in Israel?
Provide a succinct answer. 0.46. What is the ratio of the Exports(as % of merchandise exports) of 1964 in India to that in Israel?
Your answer should be very brief. 0.54. What is the ratio of the Exports(as % of merchandise exports) of 1965 in India to that in Israel?
Your response must be concise. 0.51. What is the ratio of the Exports(as % of merchandise exports) of 1962 in India to that in Italy?
Offer a terse response. 0.17. What is the ratio of the Exports(as % of merchandise exports) in 1963 in India to that in Italy?
Give a very brief answer. 0.18. What is the ratio of the Exports(as % of merchandise exports) of 1964 in India to that in Italy?
Ensure brevity in your answer.  0.27. What is the ratio of the Exports(as % of merchandise exports) in 1965 in India to that in Italy?
Your response must be concise. 0.22. What is the ratio of the Exports(as % of merchandise exports) of 1962 in Israel to that in Italy?
Provide a short and direct response. 0.24. What is the ratio of the Exports(as % of merchandise exports) in 1963 in Israel to that in Italy?
Offer a terse response. 0.4. What is the ratio of the Exports(as % of merchandise exports) of 1964 in Israel to that in Italy?
Provide a short and direct response. 0.5. What is the ratio of the Exports(as % of merchandise exports) of 1965 in Israel to that in Italy?
Make the answer very short. 0.43. What is the difference between the highest and the second highest Exports(as % of merchandise exports) in 1962?
Ensure brevity in your answer.  0.18. What is the difference between the highest and the second highest Exports(as % of merchandise exports) in 1963?
Provide a succinct answer. 0.13. What is the difference between the highest and the second highest Exports(as % of merchandise exports) of 1964?
Keep it short and to the point. 0.49. What is the difference between the highest and the second highest Exports(as % of merchandise exports) of 1965?
Provide a short and direct response. 0.63. What is the difference between the highest and the lowest Exports(as % of merchandise exports) of 1962?
Provide a short and direct response. 5.35. What is the difference between the highest and the lowest Exports(as % of merchandise exports) in 1963?
Your answer should be compact. 5.3. What is the difference between the highest and the lowest Exports(as % of merchandise exports) in 1964?
Make the answer very short. 4.88. What is the difference between the highest and the lowest Exports(as % of merchandise exports) in 1965?
Give a very brief answer. 5.4. 